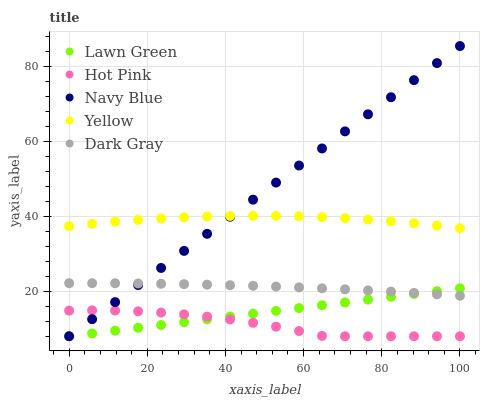Does Hot Pink have the minimum area under the curve?
Answer yes or no. Yes. Does Navy Blue have the maximum area under the curve?
Answer yes or no. Yes. Does Lawn Green have the minimum area under the curve?
Answer yes or no. No. Does Lawn Green have the maximum area under the curve?
Answer yes or no. No. Is Lawn Green the smoothest?
Answer yes or no. Yes. Is Hot Pink the roughest?
Answer yes or no. Yes. Is Hot Pink the smoothest?
Answer yes or no. No. Is Lawn Green the roughest?
Answer yes or no. No. Does Lawn Green have the lowest value?
Answer yes or no. Yes. Does Yellow have the lowest value?
Answer yes or no. No. Does Navy Blue have the highest value?
Answer yes or no. Yes. Does Lawn Green have the highest value?
Answer yes or no. No. Is Lawn Green less than Yellow?
Answer yes or no. Yes. Is Dark Gray greater than Hot Pink?
Answer yes or no. Yes. Does Hot Pink intersect Lawn Green?
Answer yes or no. Yes. Is Hot Pink less than Lawn Green?
Answer yes or no. No. Is Hot Pink greater than Lawn Green?
Answer yes or no. No. Does Lawn Green intersect Yellow?
Answer yes or no. No. 